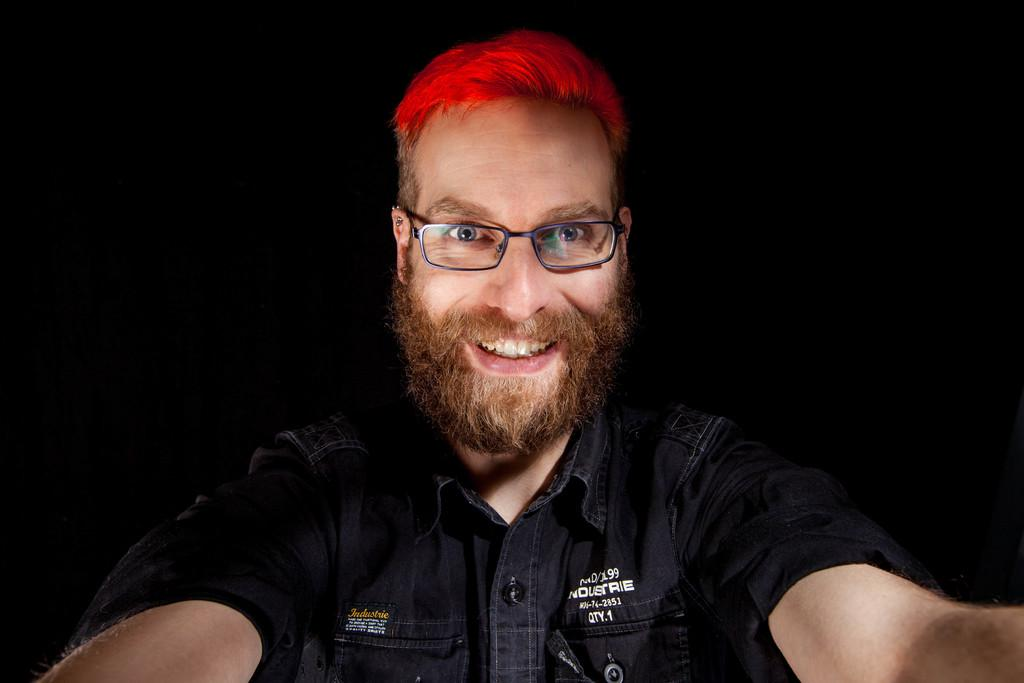What is the main subject of the image? The main subject of the image is a man. What is the man's facial expression in the image? The man is smiling in the image. What can be observed about the background of the image? The background of the image is dark. Is the man wearing a crown in the image? There is no crown visible on the man in the image. What type of feeling does the man have towards someone in the image? The image does not provide any information about the man's feelings towards someone else. 